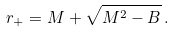Convert formula to latex. <formula><loc_0><loc_0><loc_500><loc_500>r _ { + } = M + \sqrt { M ^ { 2 } - B } \, .</formula> 